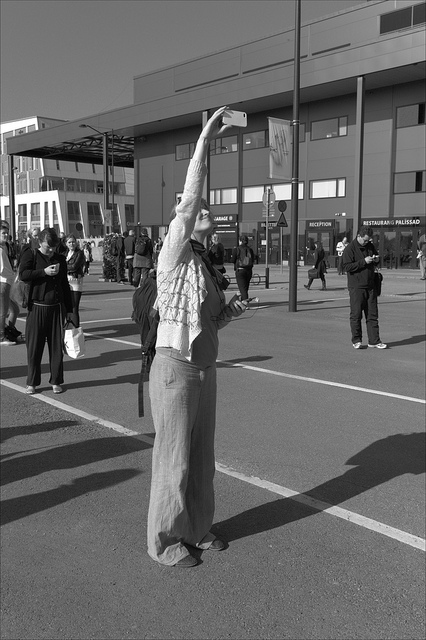<image>What type of shoes is the woman in the foreground wearing? I am not sure what type of shoes the woman in the foreground is wearing. It could be sneakers, flats, or she might not be wearing any shoes. What do the white lines on the road denote? I'm not sure about the exact meaning of the white lines on the road, it could signify lanes, crosswalk, parking spots, walking lanes, or even edges. What type of shoes is the woman in the foreground wearing? The woman in the foreground is wearing sneakers. What do the white lines on the road denote? I am not sure what the white lines on the road denote. It can be seen as crosswalk, lanes, parking spots or walking lanes. 